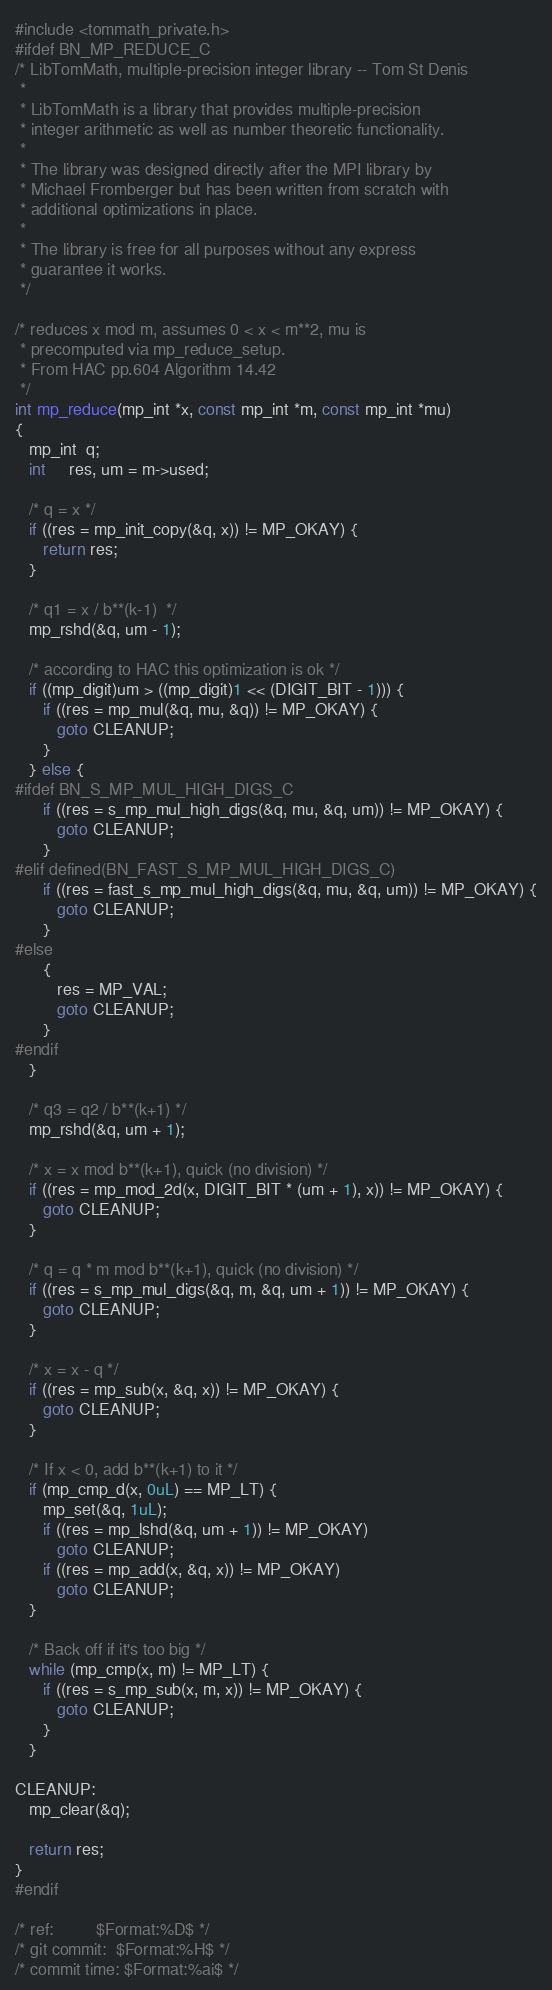<code> <loc_0><loc_0><loc_500><loc_500><_C_>#include <tommath_private.h>
#ifdef BN_MP_REDUCE_C
/* LibTomMath, multiple-precision integer library -- Tom St Denis
 *
 * LibTomMath is a library that provides multiple-precision
 * integer arithmetic as well as number theoretic functionality.
 *
 * The library was designed directly after the MPI library by
 * Michael Fromberger but has been written from scratch with
 * additional optimizations in place.
 *
 * The library is free for all purposes without any express
 * guarantee it works.
 */

/* reduces x mod m, assumes 0 < x < m**2, mu is
 * precomputed via mp_reduce_setup.
 * From HAC pp.604 Algorithm 14.42
 */
int mp_reduce(mp_int *x, const mp_int *m, const mp_int *mu)
{
   mp_int  q;
   int     res, um = m->used;

   /* q = x */
   if ((res = mp_init_copy(&q, x)) != MP_OKAY) {
      return res;
   }

   /* q1 = x / b**(k-1)  */
   mp_rshd(&q, um - 1);

   /* according to HAC this optimization is ok */
   if ((mp_digit)um > ((mp_digit)1 << (DIGIT_BIT - 1))) {
      if ((res = mp_mul(&q, mu, &q)) != MP_OKAY) {
         goto CLEANUP;
      }
   } else {
#ifdef BN_S_MP_MUL_HIGH_DIGS_C
      if ((res = s_mp_mul_high_digs(&q, mu, &q, um)) != MP_OKAY) {
         goto CLEANUP;
      }
#elif defined(BN_FAST_S_MP_MUL_HIGH_DIGS_C)
      if ((res = fast_s_mp_mul_high_digs(&q, mu, &q, um)) != MP_OKAY) {
         goto CLEANUP;
      }
#else
      {
         res = MP_VAL;
         goto CLEANUP;
      }
#endif
   }

   /* q3 = q2 / b**(k+1) */
   mp_rshd(&q, um + 1);

   /* x = x mod b**(k+1), quick (no division) */
   if ((res = mp_mod_2d(x, DIGIT_BIT * (um + 1), x)) != MP_OKAY) {
      goto CLEANUP;
   }

   /* q = q * m mod b**(k+1), quick (no division) */
   if ((res = s_mp_mul_digs(&q, m, &q, um + 1)) != MP_OKAY) {
      goto CLEANUP;
   }

   /* x = x - q */
   if ((res = mp_sub(x, &q, x)) != MP_OKAY) {
      goto CLEANUP;
   }

   /* If x < 0, add b**(k+1) to it */
   if (mp_cmp_d(x, 0uL) == MP_LT) {
      mp_set(&q, 1uL);
      if ((res = mp_lshd(&q, um + 1)) != MP_OKAY)
         goto CLEANUP;
      if ((res = mp_add(x, &q, x)) != MP_OKAY)
         goto CLEANUP;
   }

   /* Back off if it's too big */
   while (mp_cmp(x, m) != MP_LT) {
      if ((res = s_mp_sub(x, m, x)) != MP_OKAY) {
         goto CLEANUP;
      }
   }

CLEANUP:
   mp_clear(&q);

   return res;
}
#endif

/* ref:         $Format:%D$ */
/* git commit:  $Format:%H$ */
/* commit time: $Format:%ai$ */
</code> 